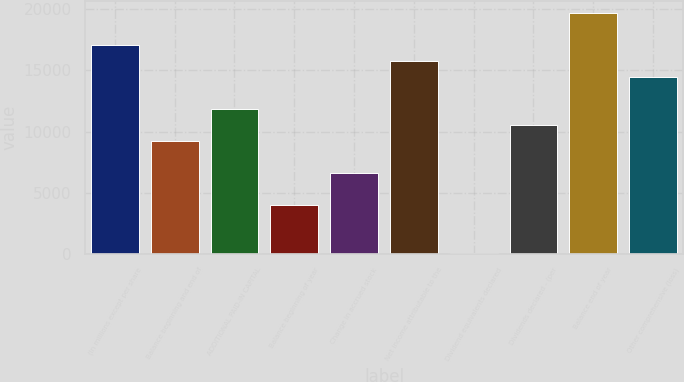Convert chart. <chart><loc_0><loc_0><loc_500><loc_500><bar_chart><fcel>(In millions except per share<fcel>Balance beginning and end of<fcel>ADDITIONAL PAID-IN CAPITAL<fcel>Balance beginning of year<fcel>Change in accrued stock<fcel>Net income attributable to the<fcel>Dividend equivalents declared<fcel>Dividends declared - (per<fcel>Balance end of year<fcel>Other comprehensive (loss)<nl><fcel>17080.2<fcel>9199.8<fcel>11826.6<fcel>3946.2<fcel>6573<fcel>15766.8<fcel>6<fcel>10513.2<fcel>19707<fcel>14453.4<nl></chart> 